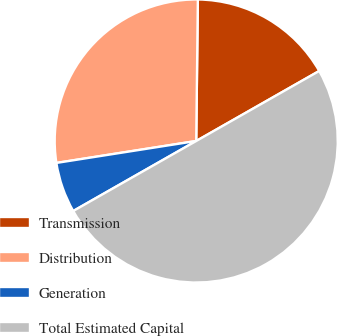<chart> <loc_0><loc_0><loc_500><loc_500><pie_chart><fcel>Transmission<fcel>Distribution<fcel>Generation<fcel>Total Estimated Capital<nl><fcel>16.58%<fcel>27.66%<fcel>5.76%<fcel>50.0%<nl></chart> 